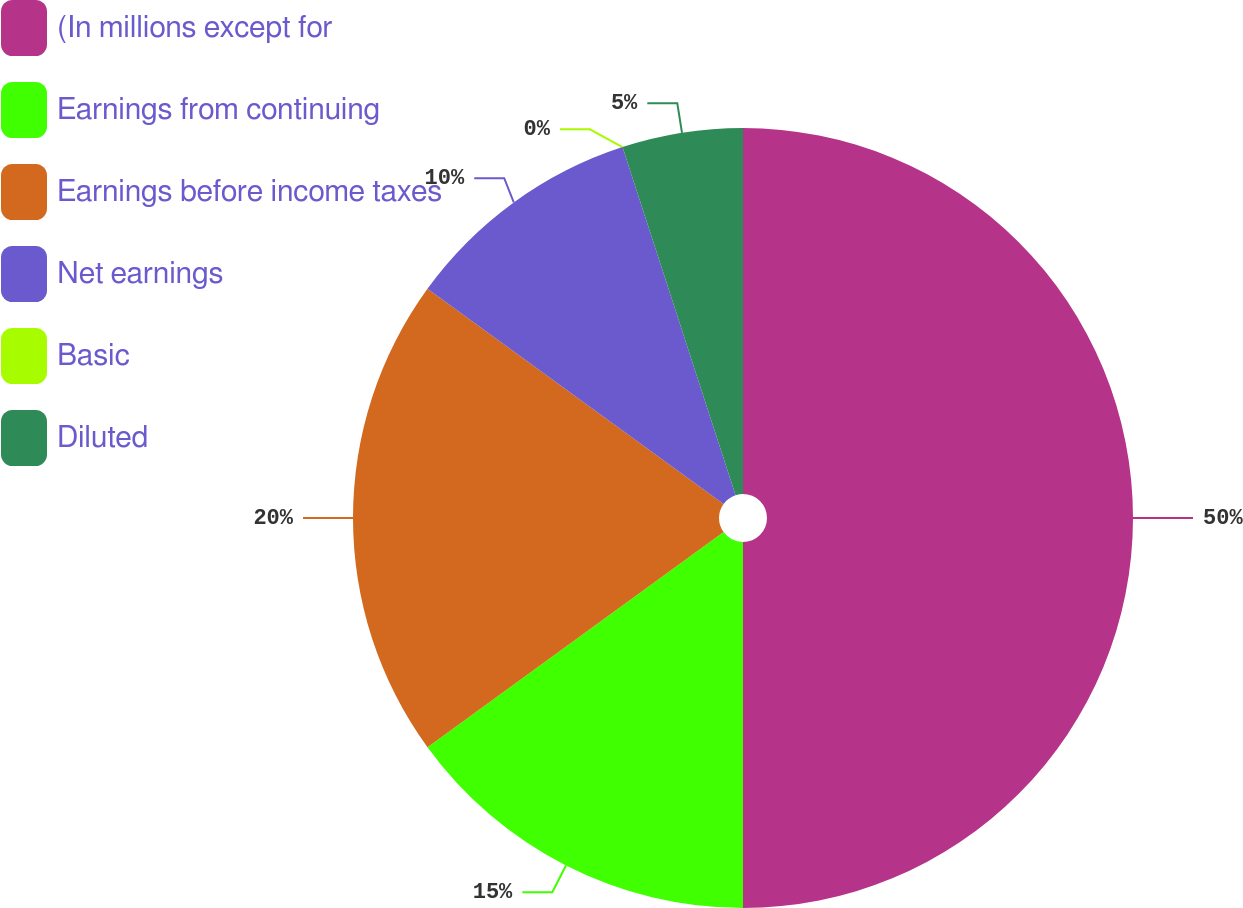Convert chart to OTSL. <chart><loc_0><loc_0><loc_500><loc_500><pie_chart><fcel>(In millions except for<fcel>Earnings from continuing<fcel>Earnings before income taxes<fcel>Net earnings<fcel>Basic<fcel>Diluted<nl><fcel>50.0%<fcel>15.0%<fcel>20.0%<fcel>10.0%<fcel>0.0%<fcel>5.0%<nl></chart> 